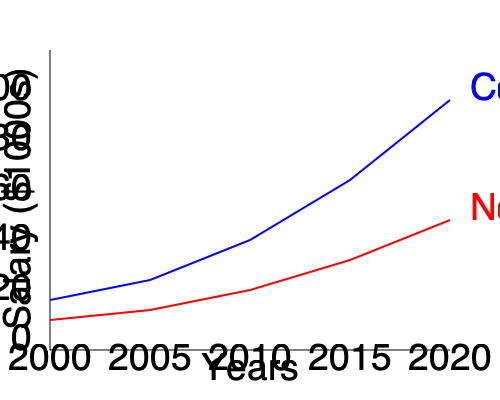Based on the salary trends shown in the graph, what is the approximate difference in annual salary between college graduates and non-graduates in 2020? To find the difference in annual salary between college graduates and non-graduates in 2020, we need to:

1. Identify the salaries for both groups in 2020 (rightmost point on the graph).
2. For college graduates (blue line):
   - The 2020 point is at approximately $90,000
3. For non-graduates (red line):
   - The 2020 point is at approximately $50,000
4. Calculate the difference:
   $90,000 - $50,000 = $40,000

Therefore, the approximate difference in annual salary between college graduates and non-graduates in 2020 is $40,000.

This significant difference highlights the potential financial benefit of pursuing a college degree, which is an important consideration for a community college student deciding whether to transfer to a four-year university or enter the workforce.
Answer: $40,000 